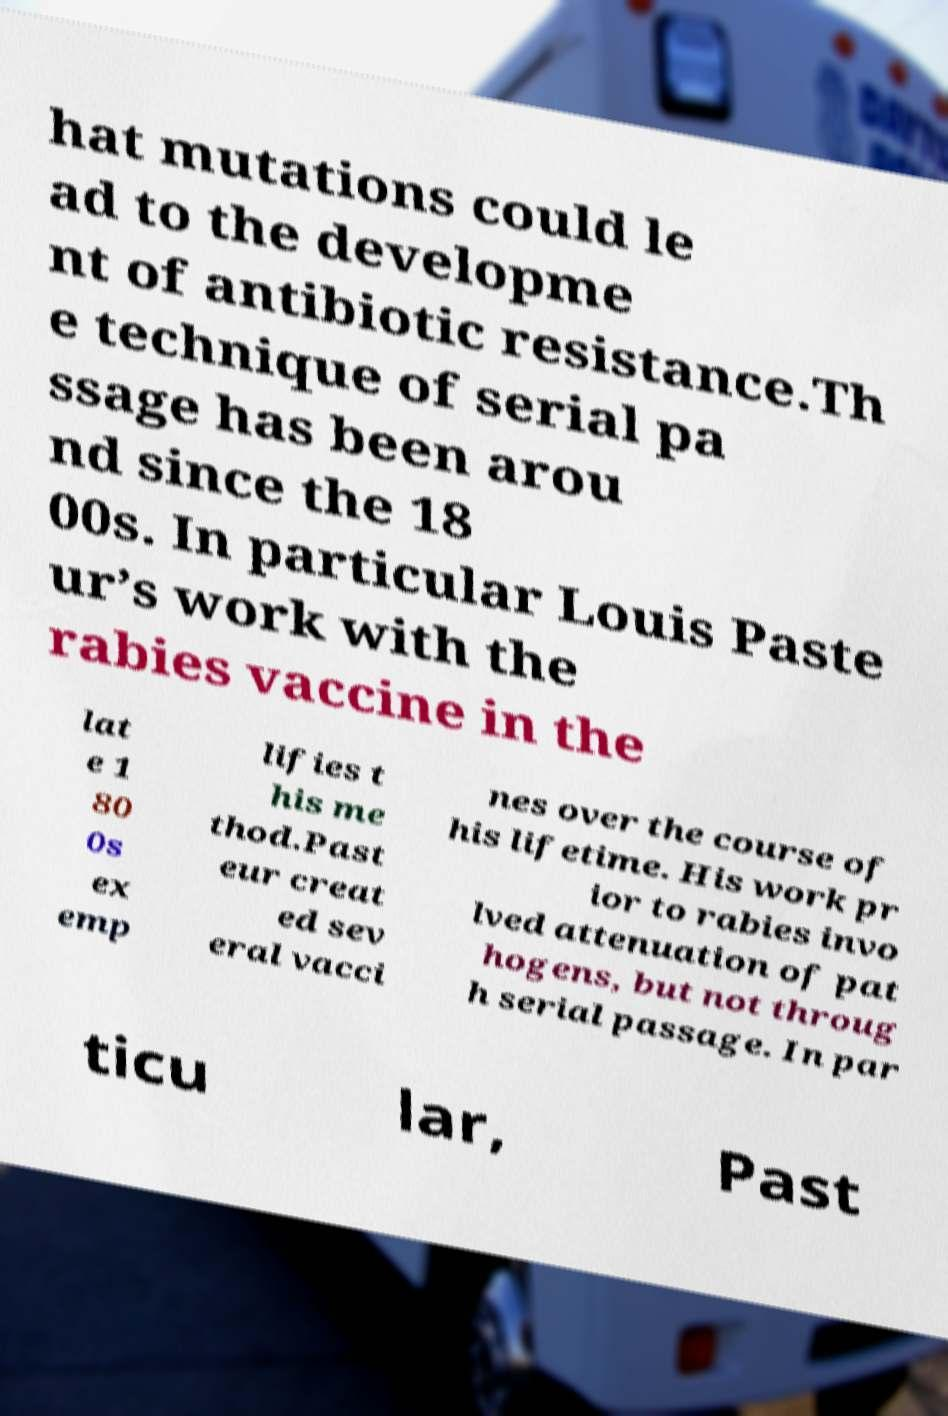Can you read and provide the text displayed in the image?This photo seems to have some interesting text. Can you extract and type it out for me? hat mutations could le ad to the developme nt of antibiotic resistance.Th e technique of serial pa ssage has been arou nd since the 18 00s. In particular Louis Paste ur’s work with the rabies vaccine in the lat e 1 80 0s ex emp lifies t his me thod.Past eur creat ed sev eral vacci nes over the course of his lifetime. His work pr ior to rabies invo lved attenuation of pat hogens, but not throug h serial passage. In par ticu lar, Past 